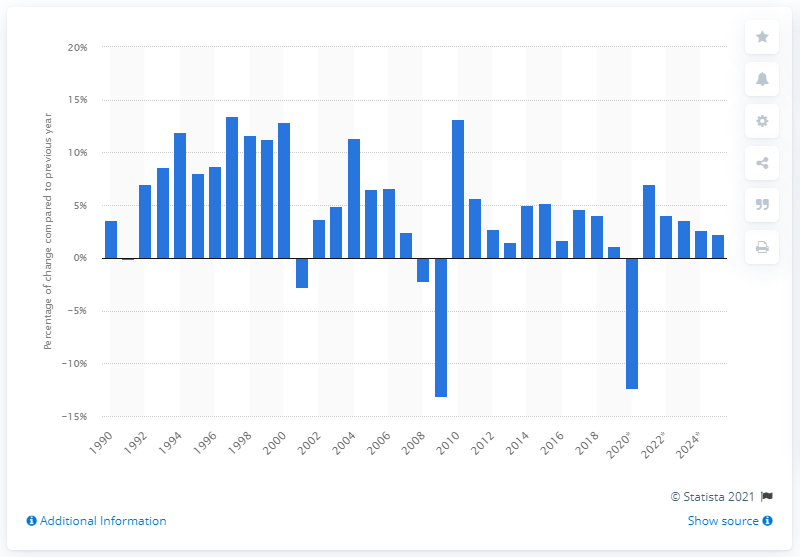Identify some key points in this picture. Imports of trade goods and services from the United States began to change in the year 1990. In 2019, the growth of imports of goods and services was 1.08 compared to the previous year. 